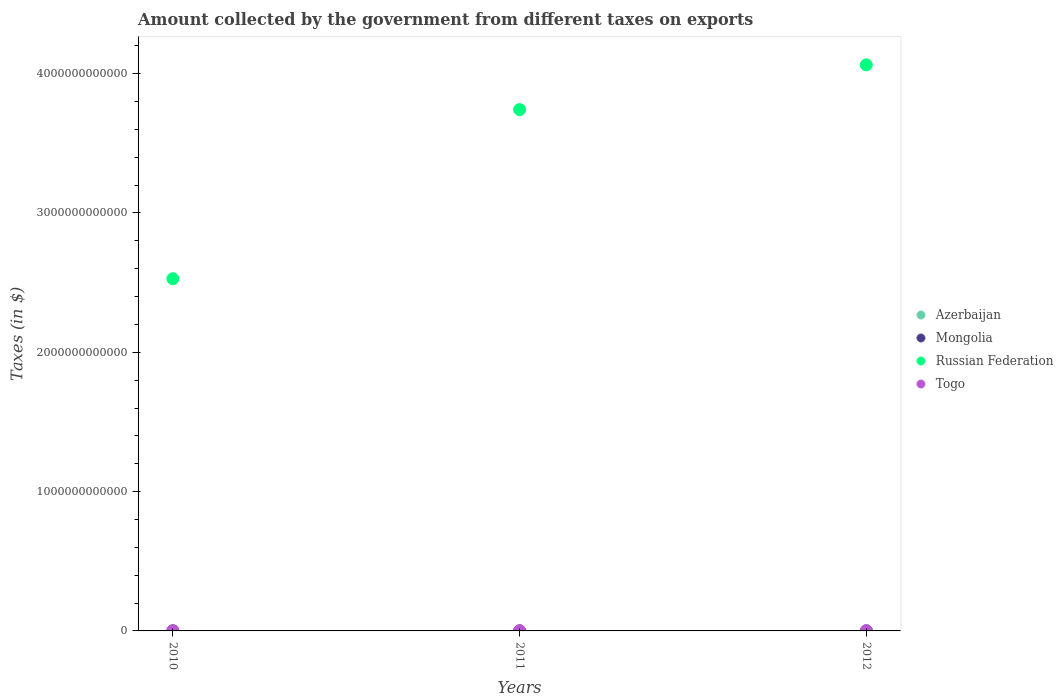How many different coloured dotlines are there?
Your answer should be compact. 4. Is the number of dotlines equal to the number of legend labels?
Give a very brief answer. Yes. Across all years, what is the maximum amount collected by the government from taxes on exports in Russian Federation?
Your answer should be very brief. 4.06e+12. Across all years, what is the minimum amount collected by the government from taxes on exports in Azerbaijan?
Keep it short and to the point. 2.00e+05. What is the total amount collected by the government from taxes on exports in Togo in the graph?
Your answer should be very brief. 4.70e+09. What is the difference between the amount collected by the government from taxes on exports in Togo in 2010 and that in 2011?
Your answer should be compact. -3.30e+08. What is the difference between the amount collected by the government from taxes on exports in Togo in 2011 and the amount collected by the government from taxes on exports in Russian Federation in 2010?
Give a very brief answer. -2.53e+12. What is the average amount collected by the government from taxes on exports in Togo per year?
Make the answer very short. 1.57e+09. In the year 2011, what is the difference between the amount collected by the government from taxes on exports in Togo and amount collected by the government from taxes on exports in Russian Federation?
Provide a short and direct response. -3.74e+12. What is the ratio of the amount collected by the government from taxes on exports in Mongolia in 2010 to that in 2011?
Your answer should be compact. 1.02. What is the difference between the highest and the second highest amount collected by the government from taxes on exports in Russian Federation?
Make the answer very short. 3.21e+11. What is the difference between the highest and the lowest amount collected by the government from taxes on exports in Mongolia?
Provide a succinct answer. 9.73e+06. In how many years, is the amount collected by the government from taxes on exports in Russian Federation greater than the average amount collected by the government from taxes on exports in Russian Federation taken over all years?
Give a very brief answer. 2. Is it the case that in every year, the sum of the amount collected by the government from taxes on exports in Mongolia and amount collected by the government from taxes on exports in Azerbaijan  is greater than the sum of amount collected by the government from taxes on exports in Togo and amount collected by the government from taxes on exports in Russian Federation?
Provide a succinct answer. No. Is it the case that in every year, the sum of the amount collected by the government from taxes on exports in Togo and amount collected by the government from taxes on exports in Russian Federation  is greater than the amount collected by the government from taxes on exports in Mongolia?
Your response must be concise. Yes. Does the amount collected by the government from taxes on exports in Azerbaijan monotonically increase over the years?
Give a very brief answer. No. Is the amount collected by the government from taxes on exports in Azerbaijan strictly less than the amount collected by the government from taxes on exports in Togo over the years?
Offer a very short reply. Yes. How many dotlines are there?
Ensure brevity in your answer.  4. How many years are there in the graph?
Offer a very short reply. 3. What is the difference between two consecutive major ticks on the Y-axis?
Make the answer very short. 1.00e+12. Are the values on the major ticks of Y-axis written in scientific E-notation?
Give a very brief answer. No. Where does the legend appear in the graph?
Ensure brevity in your answer.  Center right. What is the title of the graph?
Make the answer very short. Amount collected by the government from different taxes on exports. What is the label or title of the Y-axis?
Give a very brief answer. Taxes (in $). What is the Taxes (in $) of Azerbaijan in 2010?
Ensure brevity in your answer.  2.00e+05. What is the Taxes (in $) in Mongolia in 2010?
Offer a very short reply. 1.90e+08. What is the Taxes (in $) in Russian Federation in 2010?
Your answer should be very brief. 2.53e+12. What is the Taxes (in $) in Togo in 2010?
Provide a short and direct response. 1.43e+09. What is the Taxes (in $) in Azerbaijan in 2011?
Your response must be concise. 2.00e+05. What is the Taxes (in $) of Mongolia in 2011?
Provide a succinct answer. 1.85e+08. What is the Taxes (in $) in Russian Federation in 2011?
Give a very brief answer. 3.74e+12. What is the Taxes (in $) of Togo in 2011?
Make the answer very short. 1.76e+09. What is the Taxes (in $) of Azerbaijan in 2012?
Give a very brief answer. 8.00e+05. What is the Taxes (in $) in Mongolia in 2012?
Provide a succinct answer. 1.95e+08. What is the Taxes (in $) in Russian Federation in 2012?
Make the answer very short. 4.06e+12. What is the Taxes (in $) in Togo in 2012?
Give a very brief answer. 1.51e+09. Across all years, what is the maximum Taxes (in $) of Mongolia?
Offer a terse response. 1.95e+08. Across all years, what is the maximum Taxes (in $) in Russian Federation?
Offer a terse response. 4.06e+12. Across all years, what is the maximum Taxes (in $) in Togo?
Your answer should be very brief. 1.76e+09. Across all years, what is the minimum Taxes (in $) of Mongolia?
Ensure brevity in your answer.  1.85e+08. Across all years, what is the minimum Taxes (in $) of Russian Federation?
Your answer should be compact. 2.53e+12. Across all years, what is the minimum Taxes (in $) in Togo?
Keep it short and to the point. 1.43e+09. What is the total Taxes (in $) in Azerbaijan in the graph?
Make the answer very short. 1.20e+06. What is the total Taxes (in $) of Mongolia in the graph?
Make the answer very short. 5.71e+08. What is the total Taxes (in $) in Russian Federation in the graph?
Give a very brief answer. 1.03e+13. What is the total Taxes (in $) in Togo in the graph?
Your answer should be compact. 4.70e+09. What is the difference between the Taxes (in $) of Azerbaijan in 2010 and that in 2011?
Provide a short and direct response. 0. What is the difference between the Taxes (in $) of Mongolia in 2010 and that in 2011?
Provide a succinct answer. 4.30e+06. What is the difference between the Taxes (in $) in Russian Federation in 2010 and that in 2011?
Your answer should be compact. -1.21e+12. What is the difference between the Taxes (in $) of Togo in 2010 and that in 2011?
Provide a short and direct response. -3.30e+08. What is the difference between the Taxes (in $) of Azerbaijan in 2010 and that in 2012?
Offer a very short reply. -6.00e+05. What is the difference between the Taxes (in $) of Mongolia in 2010 and that in 2012?
Make the answer very short. -5.42e+06. What is the difference between the Taxes (in $) of Russian Federation in 2010 and that in 2012?
Your answer should be very brief. -1.54e+12. What is the difference between the Taxes (in $) in Togo in 2010 and that in 2012?
Make the answer very short. -7.58e+07. What is the difference between the Taxes (in $) of Azerbaijan in 2011 and that in 2012?
Ensure brevity in your answer.  -6.00e+05. What is the difference between the Taxes (in $) in Mongolia in 2011 and that in 2012?
Provide a short and direct response. -9.73e+06. What is the difference between the Taxes (in $) of Russian Federation in 2011 and that in 2012?
Provide a succinct answer. -3.21e+11. What is the difference between the Taxes (in $) of Togo in 2011 and that in 2012?
Keep it short and to the point. 2.54e+08. What is the difference between the Taxes (in $) of Azerbaijan in 2010 and the Taxes (in $) of Mongolia in 2011?
Provide a short and direct response. -1.85e+08. What is the difference between the Taxes (in $) of Azerbaijan in 2010 and the Taxes (in $) of Russian Federation in 2011?
Keep it short and to the point. -3.74e+12. What is the difference between the Taxes (in $) in Azerbaijan in 2010 and the Taxes (in $) in Togo in 2011?
Your answer should be compact. -1.76e+09. What is the difference between the Taxes (in $) in Mongolia in 2010 and the Taxes (in $) in Russian Federation in 2011?
Provide a short and direct response. -3.74e+12. What is the difference between the Taxes (in $) in Mongolia in 2010 and the Taxes (in $) in Togo in 2011?
Give a very brief answer. -1.57e+09. What is the difference between the Taxes (in $) in Russian Federation in 2010 and the Taxes (in $) in Togo in 2011?
Keep it short and to the point. 2.53e+12. What is the difference between the Taxes (in $) in Azerbaijan in 2010 and the Taxes (in $) in Mongolia in 2012?
Your answer should be compact. -1.95e+08. What is the difference between the Taxes (in $) of Azerbaijan in 2010 and the Taxes (in $) of Russian Federation in 2012?
Offer a terse response. -4.06e+12. What is the difference between the Taxes (in $) of Azerbaijan in 2010 and the Taxes (in $) of Togo in 2012?
Offer a terse response. -1.51e+09. What is the difference between the Taxes (in $) of Mongolia in 2010 and the Taxes (in $) of Russian Federation in 2012?
Your response must be concise. -4.06e+12. What is the difference between the Taxes (in $) of Mongolia in 2010 and the Taxes (in $) of Togo in 2012?
Keep it short and to the point. -1.32e+09. What is the difference between the Taxes (in $) of Russian Federation in 2010 and the Taxes (in $) of Togo in 2012?
Provide a short and direct response. 2.53e+12. What is the difference between the Taxes (in $) of Azerbaijan in 2011 and the Taxes (in $) of Mongolia in 2012?
Make the answer very short. -1.95e+08. What is the difference between the Taxes (in $) of Azerbaijan in 2011 and the Taxes (in $) of Russian Federation in 2012?
Give a very brief answer. -4.06e+12. What is the difference between the Taxes (in $) in Azerbaijan in 2011 and the Taxes (in $) in Togo in 2012?
Provide a short and direct response. -1.51e+09. What is the difference between the Taxes (in $) of Mongolia in 2011 and the Taxes (in $) of Russian Federation in 2012?
Provide a succinct answer. -4.06e+12. What is the difference between the Taxes (in $) of Mongolia in 2011 and the Taxes (in $) of Togo in 2012?
Give a very brief answer. -1.32e+09. What is the difference between the Taxes (in $) in Russian Federation in 2011 and the Taxes (in $) in Togo in 2012?
Provide a succinct answer. 3.74e+12. What is the average Taxes (in $) of Mongolia per year?
Your answer should be compact. 1.90e+08. What is the average Taxes (in $) of Russian Federation per year?
Your answer should be very brief. 3.44e+12. What is the average Taxes (in $) of Togo per year?
Provide a succinct answer. 1.57e+09. In the year 2010, what is the difference between the Taxes (in $) in Azerbaijan and Taxes (in $) in Mongolia?
Provide a short and direct response. -1.90e+08. In the year 2010, what is the difference between the Taxes (in $) in Azerbaijan and Taxes (in $) in Russian Federation?
Make the answer very short. -2.53e+12. In the year 2010, what is the difference between the Taxes (in $) of Azerbaijan and Taxes (in $) of Togo?
Your answer should be compact. -1.43e+09. In the year 2010, what is the difference between the Taxes (in $) of Mongolia and Taxes (in $) of Russian Federation?
Offer a terse response. -2.53e+12. In the year 2010, what is the difference between the Taxes (in $) of Mongolia and Taxes (in $) of Togo?
Provide a succinct answer. -1.24e+09. In the year 2010, what is the difference between the Taxes (in $) of Russian Federation and Taxes (in $) of Togo?
Offer a very short reply. 2.53e+12. In the year 2011, what is the difference between the Taxes (in $) of Azerbaijan and Taxes (in $) of Mongolia?
Make the answer very short. -1.85e+08. In the year 2011, what is the difference between the Taxes (in $) in Azerbaijan and Taxes (in $) in Russian Federation?
Keep it short and to the point. -3.74e+12. In the year 2011, what is the difference between the Taxes (in $) in Azerbaijan and Taxes (in $) in Togo?
Your answer should be compact. -1.76e+09. In the year 2011, what is the difference between the Taxes (in $) in Mongolia and Taxes (in $) in Russian Federation?
Ensure brevity in your answer.  -3.74e+12. In the year 2011, what is the difference between the Taxes (in $) of Mongolia and Taxes (in $) of Togo?
Give a very brief answer. -1.57e+09. In the year 2011, what is the difference between the Taxes (in $) in Russian Federation and Taxes (in $) in Togo?
Provide a short and direct response. 3.74e+12. In the year 2012, what is the difference between the Taxes (in $) in Azerbaijan and Taxes (in $) in Mongolia?
Make the answer very short. -1.94e+08. In the year 2012, what is the difference between the Taxes (in $) in Azerbaijan and Taxes (in $) in Russian Federation?
Provide a short and direct response. -4.06e+12. In the year 2012, what is the difference between the Taxes (in $) of Azerbaijan and Taxes (in $) of Togo?
Provide a succinct answer. -1.50e+09. In the year 2012, what is the difference between the Taxes (in $) in Mongolia and Taxes (in $) in Russian Federation?
Offer a terse response. -4.06e+12. In the year 2012, what is the difference between the Taxes (in $) of Mongolia and Taxes (in $) of Togo?
Offer a very short reply. -1.31e+09. In the year 2012, what is the difference between the Taxes (in $) of Russian Federation and Taxes (in $) of Togo?
Offer a terse response. 4.06e+12. What is the ratio of the Taxes (in $) in Azerbaijan in 2010 to that in 2011?
Keep it short and to the point. 1. What is the ratio of the Taxes (in $) of Mongolia in 2010 to that in 2011?
Make the answer very short. 1.02. What is the ratio of the Taxes (in $) in Russian Federation in 2010 to that in 2011?
Keep it short and to the point. 0.68. What is the ratio of the Taxes (in $) of Togo in 2010 to that in 2011?
Your answer should be very brief. 0.81. What is the ratio of the Taxes (in $) in Mongolia in 2010 to that in 2012?
Ensure brevity in your answer.  0.97. What is the ratio of the Taxes (in $) in Russian Federation in 2010 to that in 2012?
Provide a short and direct response. 0.62. What is the ratio of the Taxes (in $) in Togo in 2010 to that in 2012?
Provide a short and direct response. 0.95. What is the ratio of the Taxes (in $) of Azerbaijan in 2011 to that in 2012?
Provide a succinct answer. 0.25. What is the ratio of the Taxes (in $) in Mongolia in 2011 to that in 2012?
Provide a succinct answer. 0.95. What is the ratio of the Taxes (in $) in Russian Federation in 2011 to that in 2012?
Offer a terse response. 0.92. What is the ratio of the Taxes (in $) in Togo in 2011 to that in 2012?
Make the answer very short. 1.17. What is the difference between the highest and the second highest Taxes (in $) in Mongolia?
Offer a very short reply. 5.42e+06. What is the difference between the highest and the second highest Taxes (in $) in Russian Federation?
Provide a succinct answer. 3.21e+11. What is the difference between the highest and the second highest Taxes (in $) of Togo?
Ensure brevity in your answer.  2.54e+08. What is the difference between the highest and the lowest Taxes (in $) of Mongolia?
Give a very brief answer. 9.73e+06. What is the difference between the highest and the lowest Taxes (in $) in Russian Federation?
Ensure brevity in your answer.  1.54e+12. What is the difference between the highest and the lowest Taxes (in $) in Togo?
Ensure brevity in your answer.  3.30e+08. 